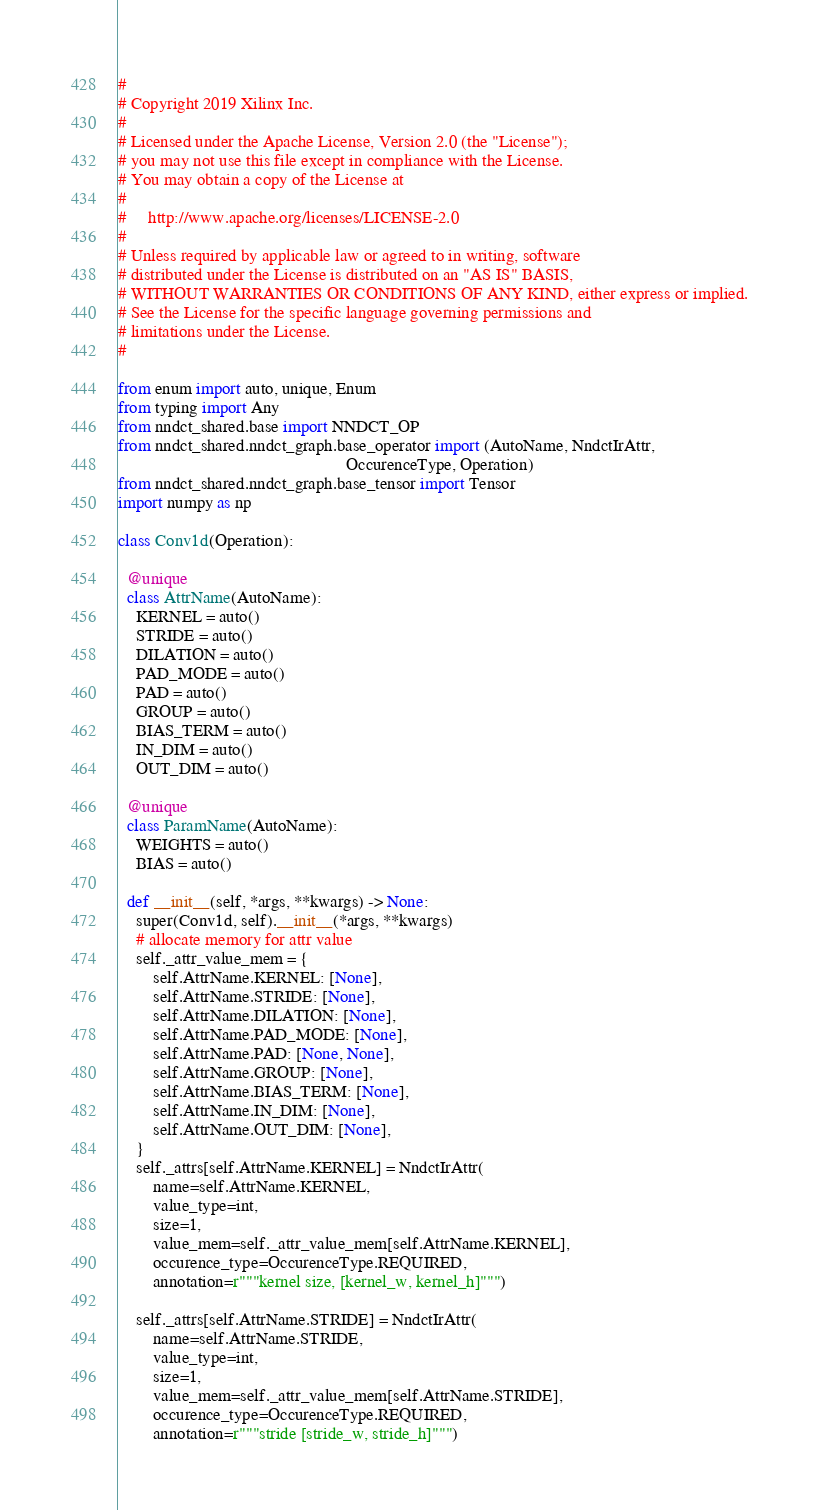Convert code to text. <code><loc_0><loc_0><loc_500><loc_500><_Python_>

#
# Copyright 2019 Xilinx Inc.
#
# Licensed under the Apache License, Version 2.0 (the "License");
# you may not use this file except in compliance with the License.
# You may obtain a copy of the License at
#
#     http://www.apache.org/licenses/LICENSE-2.0
#
# Unless required by applicable law or agreed to in writing, software
# distributed under the License is distributed on an "AS IS" BASIS,
# WITHOUT WARRANTIES OR CONDITIONS OF ANY KIND, either express or implied.
# See the License for the specific language governing permissions and
# limitations under the License.
#

from enum import auto, unique, Enum
from typing import Any
from nndct_shared.base import NNDCT_OP
from nndct_shared.nndct_graph.base_operator import (AutoName, NndctIrAttr,
                                                    OccurenceType, Operation)
from nndct_shared.nndct_graph.base_tensor import Tensor
import numpy as np

class Conv1d(Operation):

  @unique
  class AttrName(AutoName):
    KERNEL = auto()
    STRIDE = auto()
    DILATION = auto()
    PAD_MODE = auto()
    PAD = auto()
    GROUP = auto()
    BIAS_TERM = auto()
    IN_DIM = auto()
    OUT_DIM = auto()

  @unique
  class ParamName(AutoName):
    WEIGHTS = auto()
    BIAS = auto()

  def __init__(self, *args, **kwargs) -> None:
    super(Conv1d, self).__init__(*args, **kwargs)
    # allocate memory for attr value
    self._attr_value_mem = {
        self.AttrName.KERNEL: [None],
        self.AttrName.STRIDE: [None],
        self.AttrName.DILATION: [None],
        self.AttrName.PAD_MODE: [None],
        self.AttrName.PAD: [None, None],
        self.AttrName.GROUP: [None],
        self.AttrName.BIAS_TERM: [None],
        self.AttrName.IN_DIM: [None],
        self.AttrName.OUT_DIM: [None],
    }
    self._attrs[self.AttrName.KERNEL] = NndctIrAttr(
        name=self.AttrName.KERNEL,
        value_type=int,
        size=1,
        value_mem=self._attr_value_mem[self.AttrName.KERNEL],
        occurence_type=OccurenceType.REQUIRED,
        annotation=r"""kernel size, [kernel_w, kernel_h]""")

    self._attrs[self.AttrName.STRIDE] = NndctIrAttr(
        name=self.AttrName.STRIDE,
        value_type=int,
        size=1,
        value_mem=self._attr_value_mem[self.AttrName.STRIDE],
        occurence_type=OccurenceType.REQUIRED,
        annotation=r"""stride [stride_w, stride_h]""")
</code> 